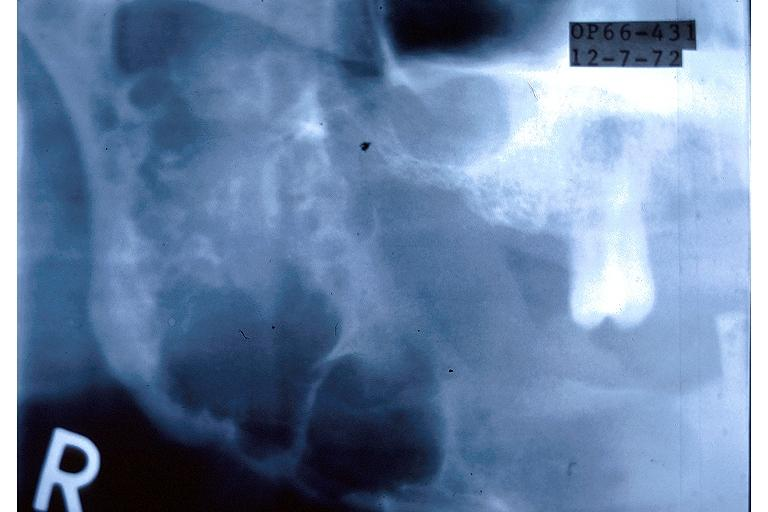s oral present?
Answer the question using a single word or phrase. Yes 